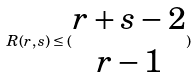<formula> <loc_0><loc_0><loc_500><loc_500>R ( r , s ) \leq ( \begin{matrix} r + s - 2 \\ r - 1 \end{matrix} )</formula> 